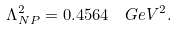Convert formula to latex. <formula><loc_0><loc_0><loc_500><loc_500>\Lambda ^ { 2 } _ { N P } = 0 . 4 5 6 4 \ \ G e V ^ { 2 } .</formula> 